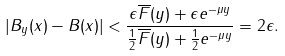Convert formula to latex. <formula><loc_0><loc_0><loc_500><loc_500>| B _ { y } ( x ) - B ( x ) | < \frac { \epsilon \overline { F } ( y ) + \epsilon e ^ { - \mu y } } { \frac { 1 } { 2 } \overline { F } ( y ) + \frac { 1 } { 2 } e ^ { - \mu y } } = 2 \epsilon .</formula> 